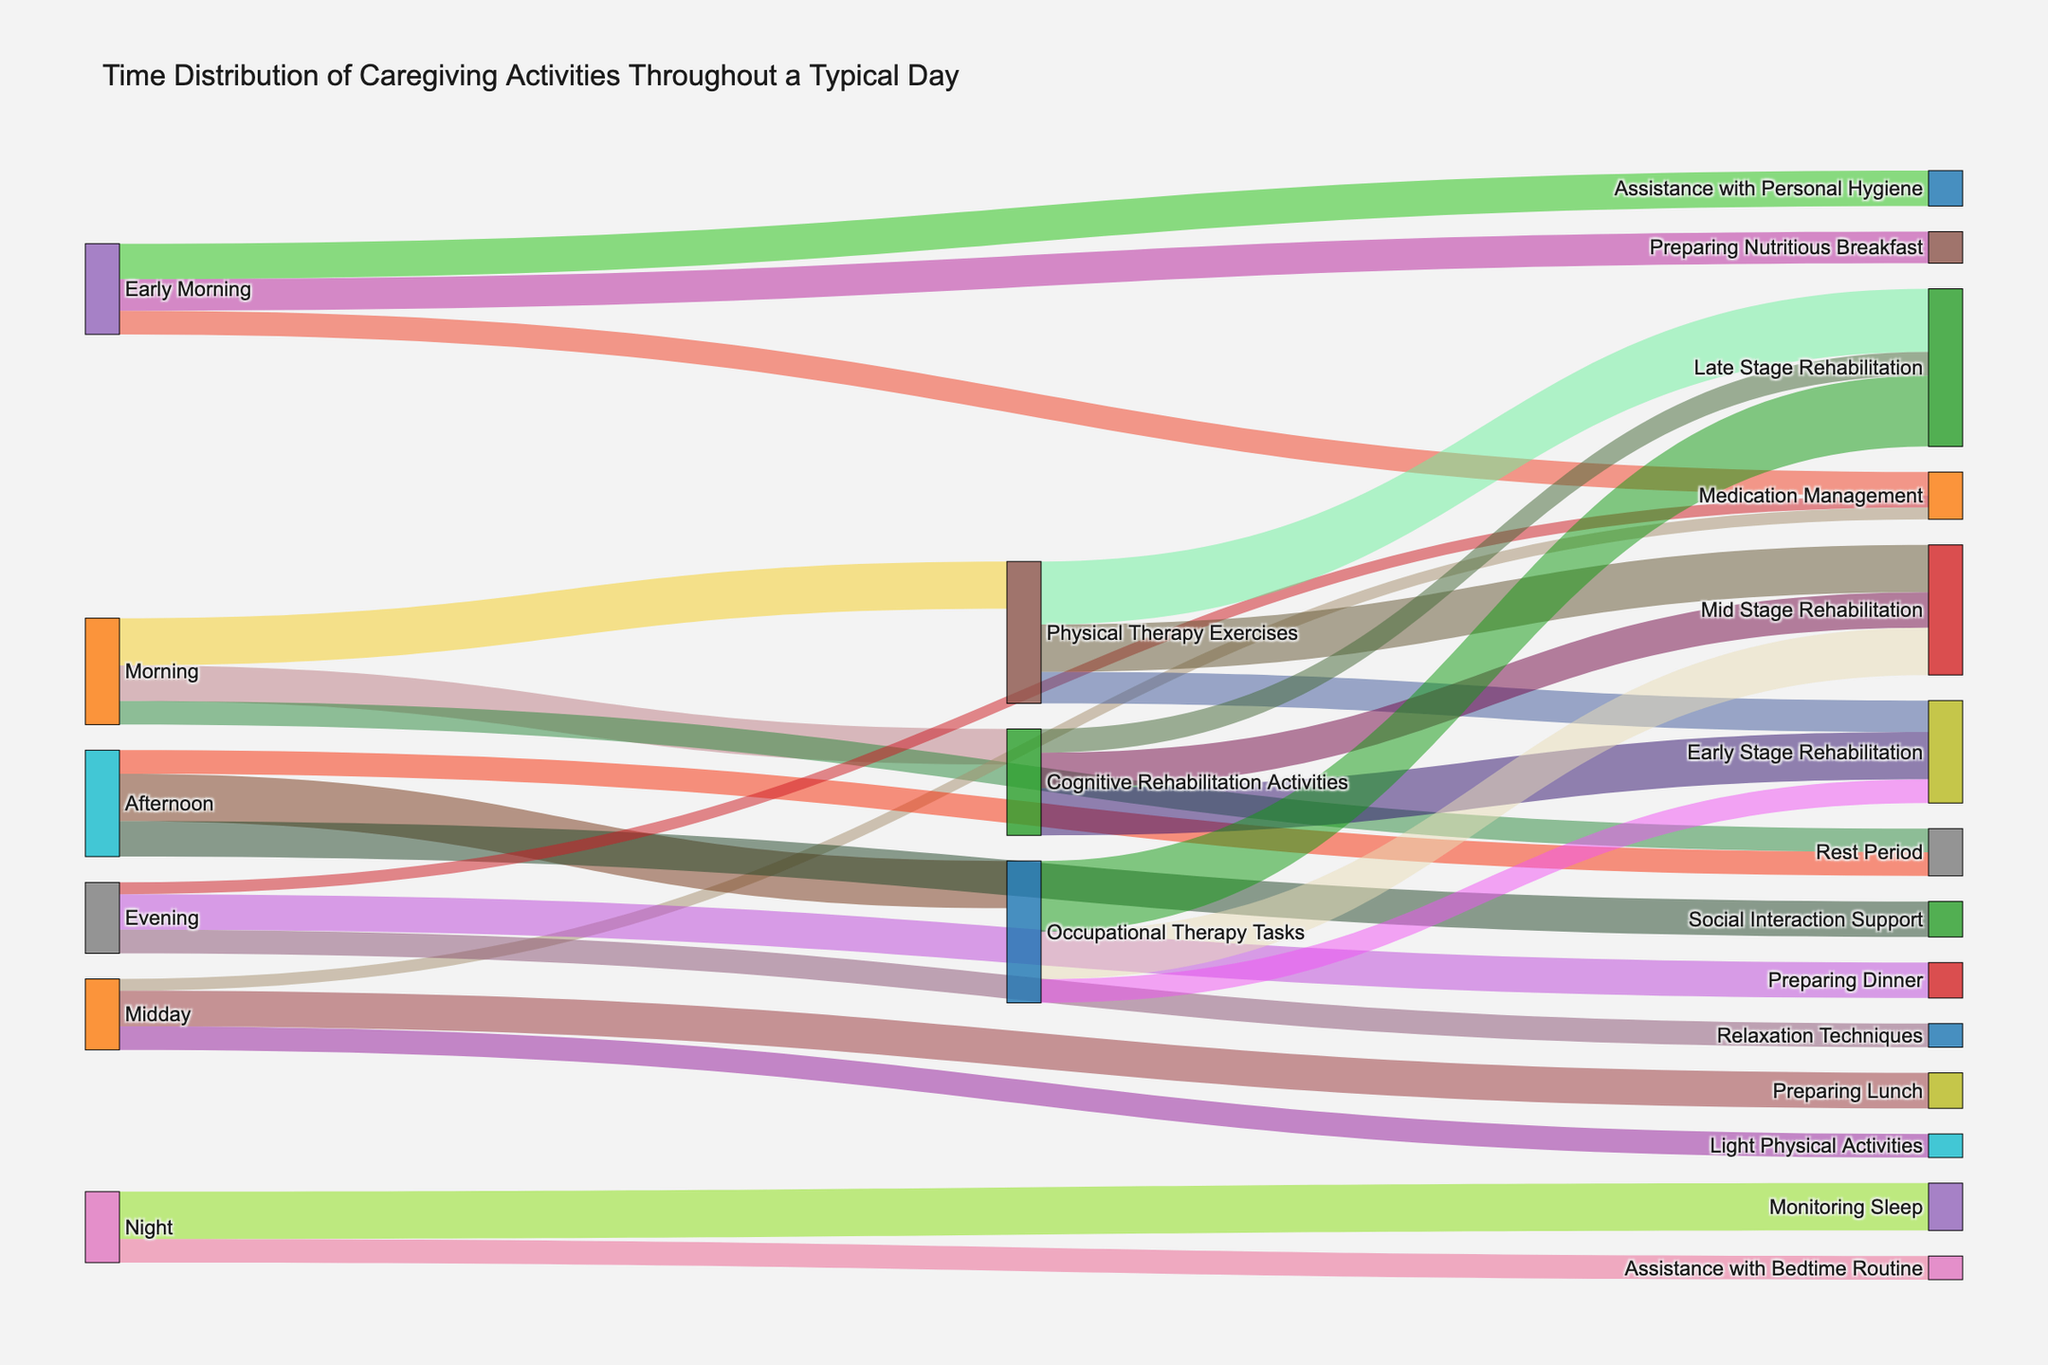What is the title of the Sankey diagram? The title is displayed at the top of the figure in larger text, providing a summary of the chart's content. It states "Time Distribution of Caregiving Activities Throughout a Typical Day".
Answer: Time Distribution of Caregiving Activities Throughout a Typical Day During which period of the day is the most time spent on cognitive rehabilitation activities? By tracing the flow from the "Cognitive Rehabilitation Activities" node, we see it connects to different times of the day nodes. The longest flow connects to "Morning".
Answer: Morning Which caregiving activity has the highest value connected to "Mid Stage Rehabilitation"? From the connections originating from "Mid Stage Rehabilitation", we observe the values: Physical Therapy Exercises (60), Cognitive Rehabilitation Activities (45), and Occupational Therapy Tasks (60). Both Physical Therapy Exercises and Occupational Therapy Tasks have an equal highest value of 60.
Answer: Physical Therapy Exercises and Occupational Therapy Tasks How much total time is spent on rest periods throughout the day? Adding up the values associated with "Rest Period" throughout the day: Morning (30) and Afternoon (30). The sum is 30 + 30 which totals 60.
Answer: 60 Which caregiving activity shows the largest increase in time from early to late stage rehabilitation? Comparing the values from early to late stage for all activities: Physical Therapy Exercises (40 to 80), Cognitive Rehabilitation Activities (60 to 30), and Occupational Therapy Tasks (30 to 90). Occupational Therapy Tasks show an increase of 60 minutes (from 30 to 90).
Answer: Occupational Therapy Tasks How much total time is spent on medication management throughout the day? Summing up the times for "Medication Management" from Early Morning (30), Midday (15), and Evening (15). The total is 30 + 15 + 15 which equals 60.
Answer: 60 Between "Social Interaction Support" and "Relaxation Techniques", which has more time allocated and by how much? Checking values for Social Interaction Support (45) and Relaxation Techniques (30). The difference is 45 - 30 = 15.
Answer: Social Interaction Support by 15 During which period of the day is the least time spent on caregiving activities? Comparing total times for all activities in each period, we find Night (Assistance with Bedtime Routine: 30, Monitoring Sleep: 60 = 90) is more than Early Morning (30 + 45 + 40 = 115), Morning (60 + 45 + 30 = 135), Midday (45 + 15 + 30 = 90), Afternoon (60 + 45 + 30 = 135), and Evening (45 + 15 + 30 = 90). Night has the least with 90 minutes.
Answer: Night How does the time assigned to "Assistance with Personal Hygiene" in Early Morning compare to time spent on "Relaxation Techniques" in Evening? The value for "Assistance with Personal Hygiene" in Early Morning is 45, and "Relaxation Techniques" in Evening is 30. Comparing these values, 45 is greater than 30.
Answer: Higher for Assistance with Personal Hygiene by 15 What is the total time spent on rehabilitation activities (Physical Therapy Exercises, Cognitive Rehabilitation Activities, Occupational Therapy Tasks) in the Late Stage Rehabilitation? Summing the values for Late Stage Rehabilitation: Physical Therapy Exercises (80), Cognitive Rehabilitation Activities (30), and Occupational Therapy Tasks (90). Total is 80 + 30 + 90 = 200.
Answer: 200 